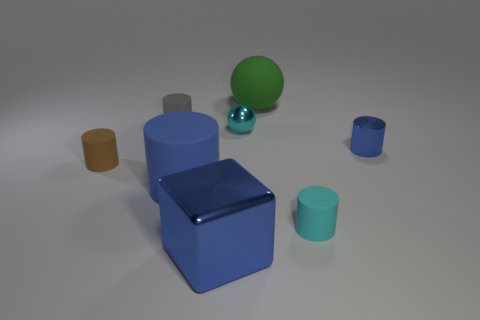Is there anything else that has the same size as the gray rubber cylinder?
Provide a succinct answer. Yes. Are there any other blue blocks of the same size as the block?
Your answer should be very brief. No. Does the large green thing have the same material as the cyan thing in front of the big blue rubber cylinder?
Offer a very short reply. Yes. Is the number of green rubber objects greater than the number of small yellow metal cubes?
Make the answer very short. Yes. What number of cylinders are either small brown rubber objects or tiny cyan metallic things?
Offer a terse response. 1. What is the color of the cube?
Keep it short and to the point. Blue. There is a ball behind the tiny gray cylinder; is it the same size as the blue metal object to the right of the green matte thing?
Offer a terse response. No. Is the number of blue metal cubes less than the number of small red matte cubes?
Offer a terse response. No. There is a large green thing; how many large rubber things are in front of it?
Ensure brevity in your answer.  1. What is the large cylinder made of?
Offer a very short reply. Rubber. 